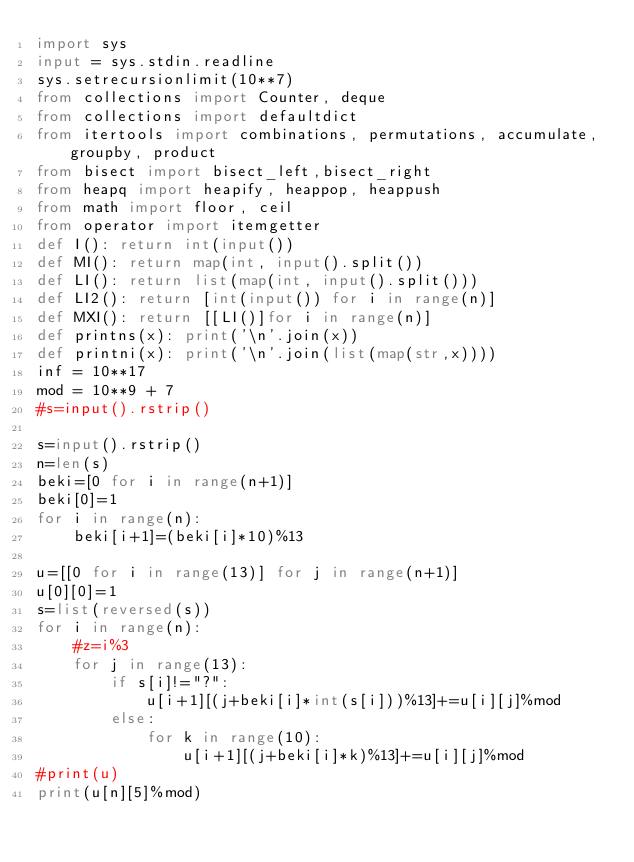<code> <loc_0><loc_0><loc_500><loc_500><_Python_>import sys
input = sys.stdin.readline
sys.setrecursionlimit(10**7)
from collections import Counter, deque
from collections import defaultdict
from itertools import combinations, permutations, accumulate, groupby, product
from bisect import bisect_left,bisect_right
from heapq import heapify, heappop, heappush
from math import floor, ceil
from operator import itemgetter
def I(): return int(input())
def MI(): return map(int, input().split())
def LI(): return list(map(int, input().split()))
def LI2(): return [int(input()) for i in range(n)]
def MXI(): return [[LI()]for i in range(n)]
def printns(x): print('\n'.join(x))
def printni(x): print('\n'.join(list(map(str,x))))
inf = 10**17
mod = 10**9 + 7
#s=input().rstrip()

s=input().rstrip()
n=len(s)
beki=[0 for i in range(n+1)]
beki[0]=1
for i in range(n):
    beki[i+1]=(beki[i]*10)%13

u=[[0 for i in range(13)] for j in range(n+1)]
u[0][0]=1
s=list(reversed(s))
for i in range(n):
    #z=i%3
    for j in range(13):
        if s[i]!="?":
            u[i+1][(j+beki[i]*int(s[i]))%13]+=u[i][j]%mod
        else:
            for k in range(10):
                u[i+1][(j+beki[i]*k)%13]+=u[i][j]%mod
#print(u)
print(u[n][5]%mod)</code> 